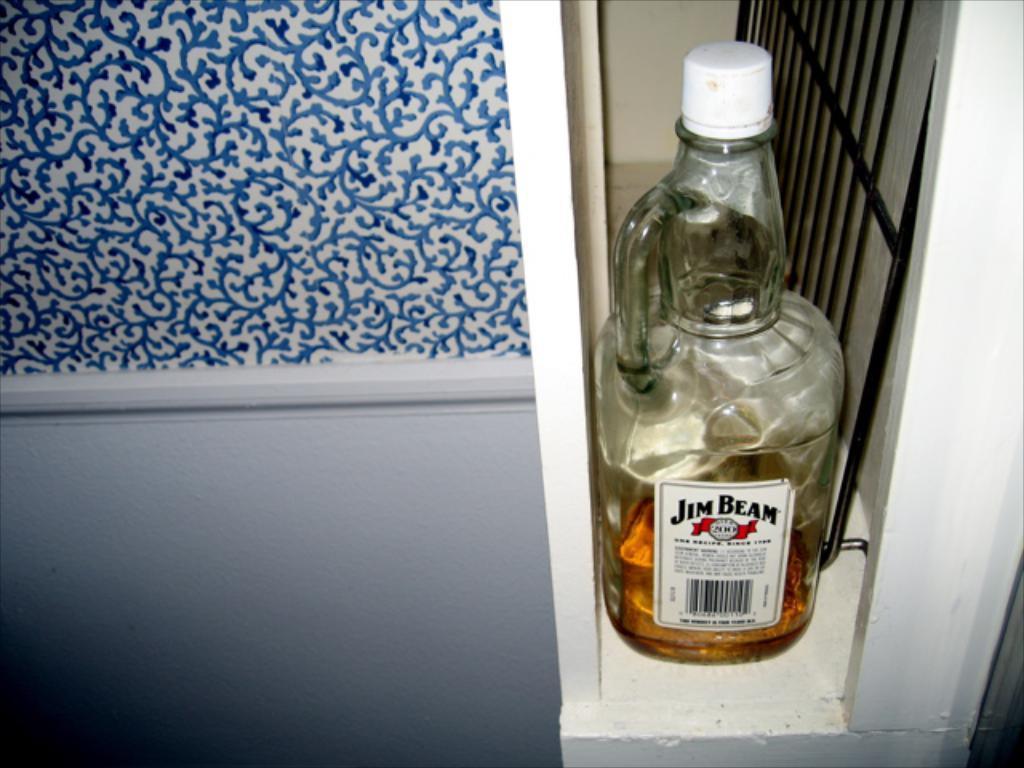Please provide a concise description of this image. This bottle is highlighted in this picture. On this bottle there is a sticker. This is grill. 